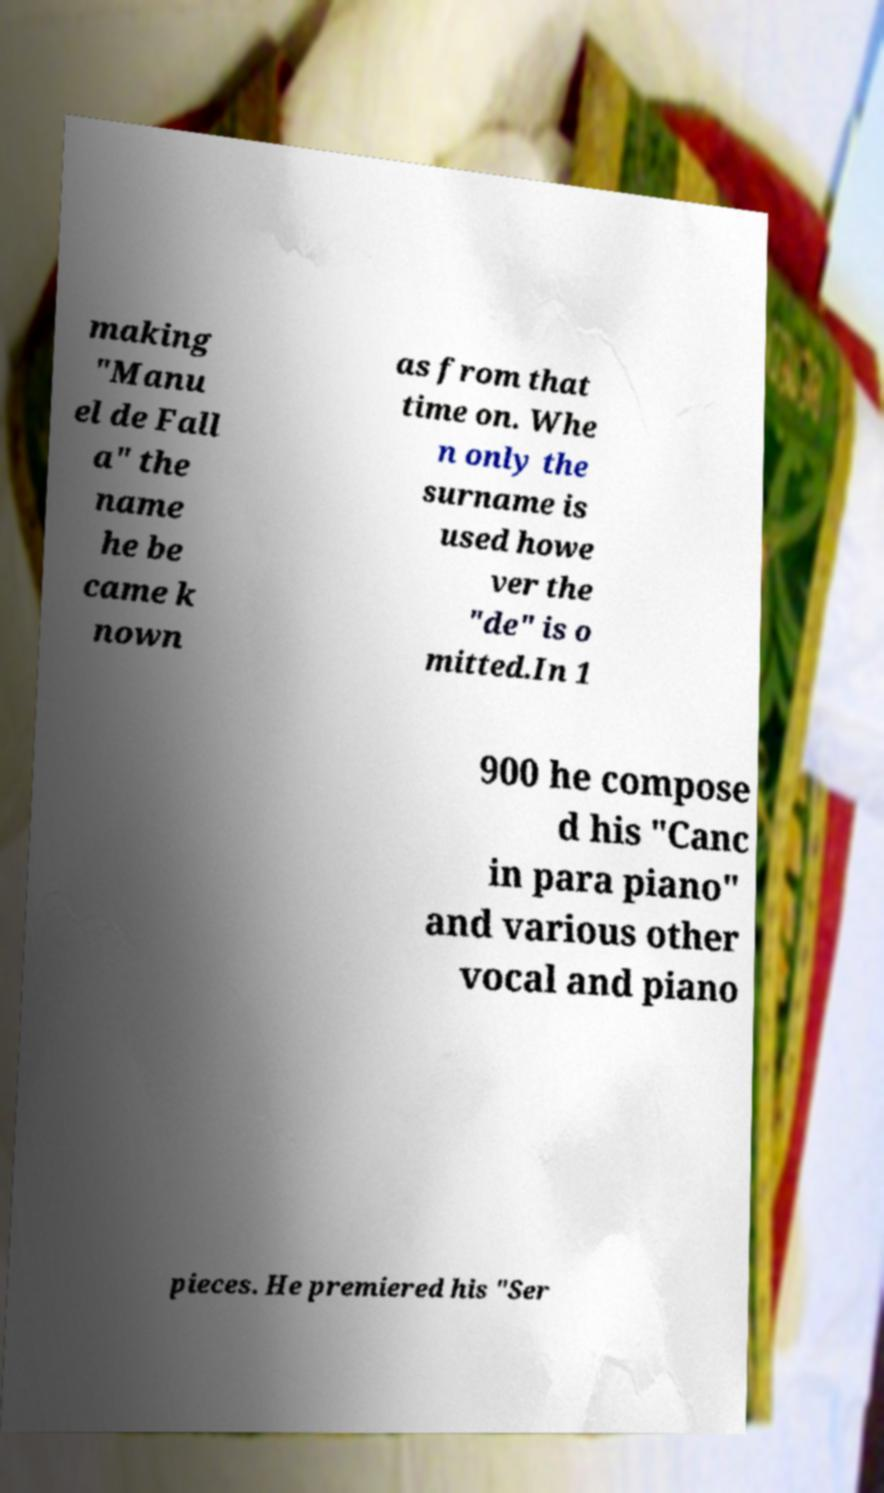There's text embedded in this image that I need extracted. Can you transcribe it verbatim? making "Manu el de Fall a" the name he be came k nown as from that time on. Whe n only the surname is used howe ver the "de" is o mitted.In 1 900 he compose d his "Canc in para piano" and various other vocal and piano pieces. He premiered his "Ser 